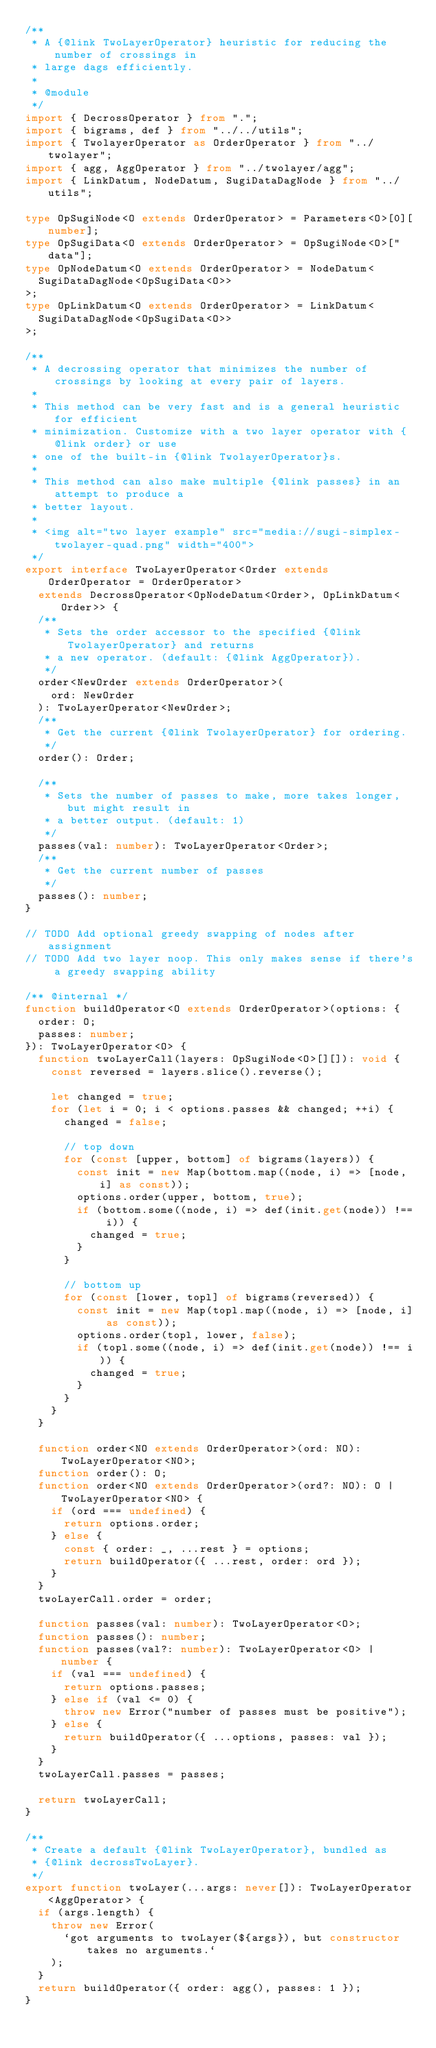<code> <loc_0><loc_0><loc_500><loc_500><_TypeScript_>/**
 * A {@link TwoLayerOperator} heuristic for reducing the number of crossings in
 * large dags efficiently.
 *
 * @module
 */
import { DecrossOperator } from ".";
import { bigrams, def } from "../../utils";
import { TwolayerOperator as OrderOperator } from "../twolayer";
import { agg, AggOperator } from "../twolayer/agg";
import { LinkDatum, NodeDatum, SugiDataDagNode } from "../utils";

type OpSugiNode<O extends OrderOperator> = Parameters<O>[0][number];
type OpSugiData<O extends OrderOperator> = OpSugiNode<O>["data"];
type OpNodeDatum<O extends OrderOperator> = NodeDatum<
  SugiDataDagNode<OpSugiData<O>>
>;
type OpLinkDatum<O extends OrderOperator> = LinkDatum<
  SugiDataDagNode<OpSugiData<O>>
>;

/**
 * A decrossing operator that minimizes the number of crossings by looking at every pair of layers.
 *
 * This method can be very fast and is a general heuristic for efficient
 * minimization. Customize with a two layer operator with {@link order} or use
 * one of the built-in {@link TwolayerOperator}s.
 *
 * This method can also make multiple {@link passes} in an attempt to produce a
 * better layout.
 *
 * <img alt="two layer example" src="media://sugi-simplex-twolayer-quad.png" width="400">
 */
export interface TwoLayerOperator<Order extends OrderOperator = OrderOperator>
  extends DecrossOperator<OpNodeDatum<Order>, OpLinkDatum<Order>> {
  /**
   * Sets the order accessor to the specified {@link TwolayerOperator} and returns
   * a new operator. (default: {@link AggOperator}).
   */
  order<NewOrder extends OrderOperator>(
    ord: NewOrder
  ): TwoLayerOperator<NewOrder>;
  /**
   * Get the current {@link TwolayerOperator} for ordering.
   */
  order(): Order;

  /**
   * Sets the number of passes to make, more takes longer, but might result in
   * a better output. (default: 1)
   */
  passes(val: number): TwoLayerOperator<Order>;
  /**
   * Get the current number of passes
   */
  passes(): number;
}

// TODO Add optional greedy swapping of nodes after assignment
// TODO Add two layer noop. This only makes sense if there's a greedy swapping ability

/** @internal */
function buildOperator<O extends OrderOperator>(options: {
  order: O;
  passes: number;
}): TwoLayerOperator<O> {
  function twoLayerCall(layers: OpSugiNode<O>[][]): void {
    const reversed = layers.slice().reverse();

    let changed = true;
    for (let i = 0; i < options.passes && changed; ++i) {
      changed = false;

      // top down
      for (const [upper, bottom] of bigrams(layers)) {
        const init = new Map(bottom.map((node, i) => [node, i] as const));
        options.order(upper, bottom, true);
        if (bottom.some((node, i) => def(init.get(node)) !== i)) {
          changed = true;
        }
      }

      // bottom up
      for (const [lower, topl] of bigrams(reversed)) {
        const init = new Map(topl.map((node, i) => [node, i] as const));
        options.order(topl, lower, false);
        if (topl.some((node, i) => def(init.get(node)) !== i)) {
          changed = true;
        }
      }
    }
  }

  function order<NO extends OrderOperator>(ord: NO): TwoLayerOperator<NO>;
  function order(): O;
  function order<NO extends OrderOperator>(ord?: NO): O | TwoLayerOperator<NO> {
    if (ord === undefined) {
      return options.order;
    } else {
      const { order: _, ...rest } = options;
      return buildOperator({ ...rest, order: ord });
    }
  }
  twoLayerCall.order = order;

  function passes(val: number): TwoLayerOperator<O>;
  function passes(): number;
  function passes(val?: number): TwoLayerOperator<O> | number {
    if (val === undefined) {
      return options.passes;
    } else if (val <= 0) {
      throw new Error("number of passes must be positive");
    } else {
      return buildOperator({ ...options, passes: val });
    }
  }
  twoLayerCall.passes = passes;

  return twoLayerCall;
}

/**
 * Create a default {@link TwoLayerOperator}, bundled as
 * {@link decrossTwoLayer}.
 */
export function twoLayer(...args: never[]): TwoLayerOperator<AggOperator> {
  if (args.length) {
    throw new Error(
      `got arguments to twoLayer(${args}), but constructor takes no arguments.`
    );
  }
  return buildOperator({ order: agg(), passes: 1 });
}
</code> 